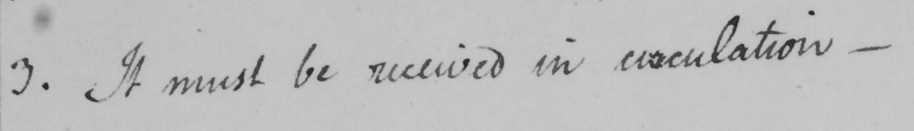Transcribe the text shown in this historical manuscript line. 3 . It must be received in circulation  _ 